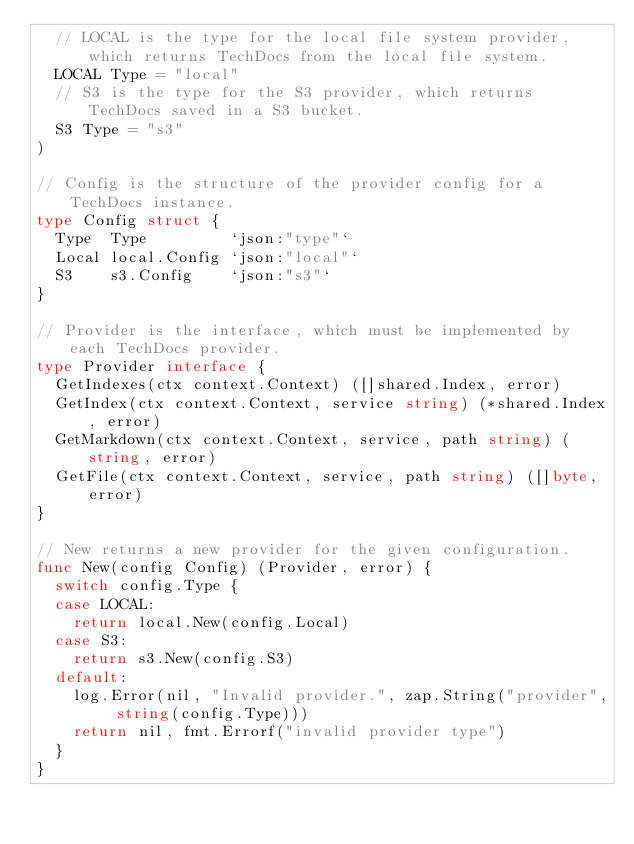Convert code to text. <code><loc_0><loc_0><loc_500><loc_500><_Go_>	// LOCAL is the type for the local file system provider, which returns TechDocs from the local file system.
	LOCAL Type = "local"
	// S3 is the type for the S3 provider, which returns TechDocs saved in a S3 bucket.
	S3 Type = "s3"
)

// Config is the structure of the provider config for a TechDocs instance.
type Config struct {
	Type  Type         `json:"type"`
	Local local.Config `json:"local"`
	S3    s3.Config    `json:"s3"`
}

// Provider is the interface, which must be implemented by each TechDocs provider.
type Provider interface {
	GetIndexes(ctx context.Context) ([]shared.Index, error)
	GetIndex(ctx context.Context, service string) (*shared.Index, error)
	GetMarkdown(ctx context.Context, service, path string) (string, error)
	GetFile(ctx context.Context, service, path string) ([]byte, error)
}

// New returns a new provider for the given configuration.
func New(config Config) (Provider, error) {
	switch config.Type {
	case LOCAL:
		return local.New(config.Local)
	case S3:
		return s3.New(config.S3)
	default:
		log.Error(nil, "Invalid provider.", zap.String("provider", string(config.Type)))
		return nil, fmt.Errorf("invalid provider type")
	}
}
</code> 